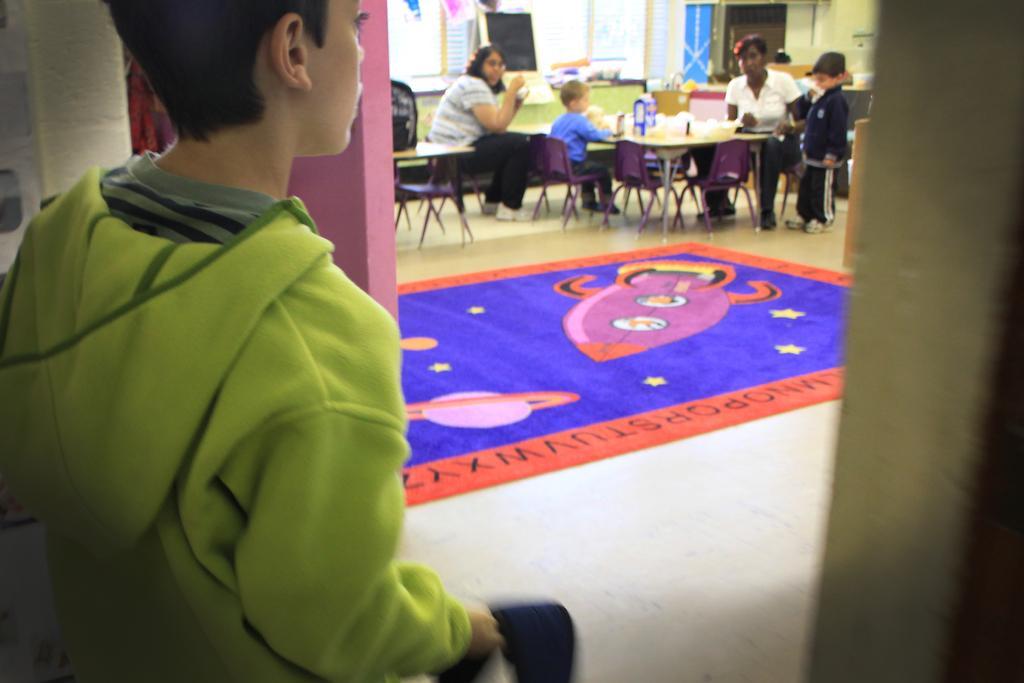How would you summarize this image in a sentence or two? In this image I can see there are two women and two boys visible in front of the table and one boy and one woman sitting on the chair and another boy standing on the floor and I can see blue color carpet in the middle. And I can see a boy wearing a green color t-shirt on the left side. 